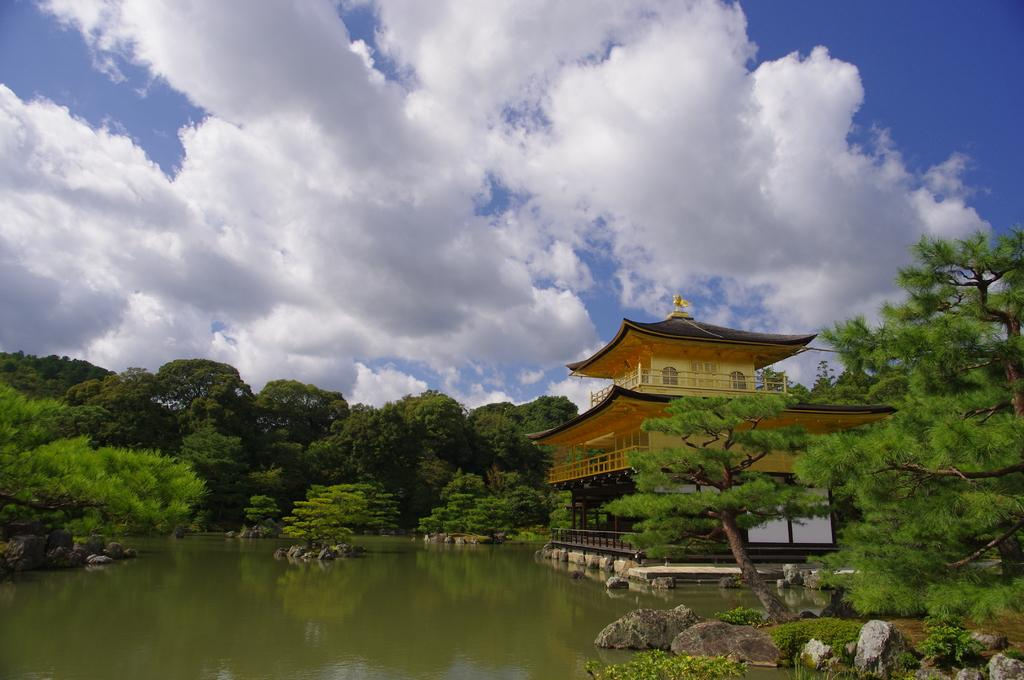What type of natural body of water can be seen in the background of the image? There is a lake in the background of the image. What other natural elements are present in the background of the image? There are trees in the background of the image. Are there any man-made structures visible in the background? Yes, there is a house in the background of the image. What is visible in the sky in the background of the image? The sky is visible in the background of the image. What type of jam is being spread on the beef in the image? There is no beef or jam present in the image; it features a lake, trees, a house, and the sky. 